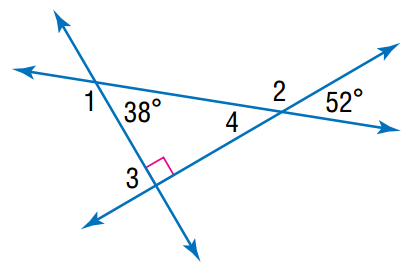Answer the mathemtical geometry problem and directly provide the correct option letter.
Question: Find the angle measure of \angle 3.
Choices: A: 38 B: 52 C: 90 D: 180 C 